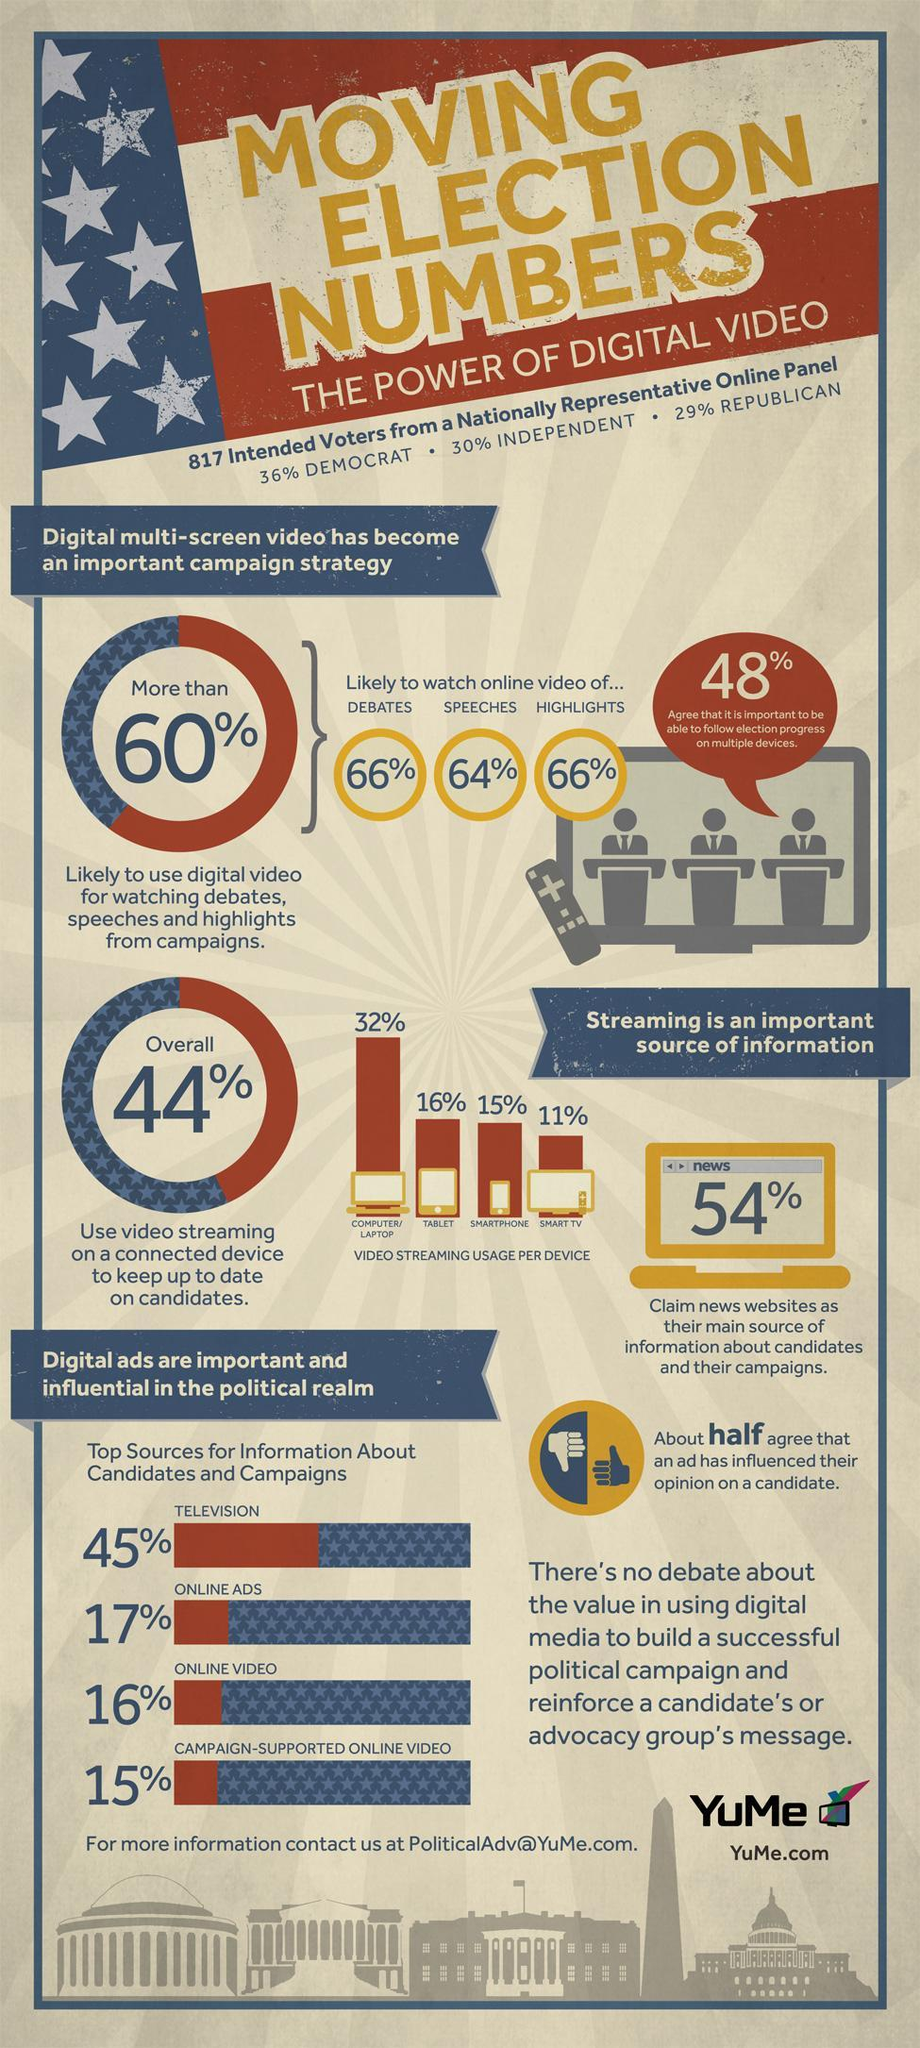What percent of information about the candidates & campaigns is sourced by the online ads?
Answer the question with a short phrase. 17% 